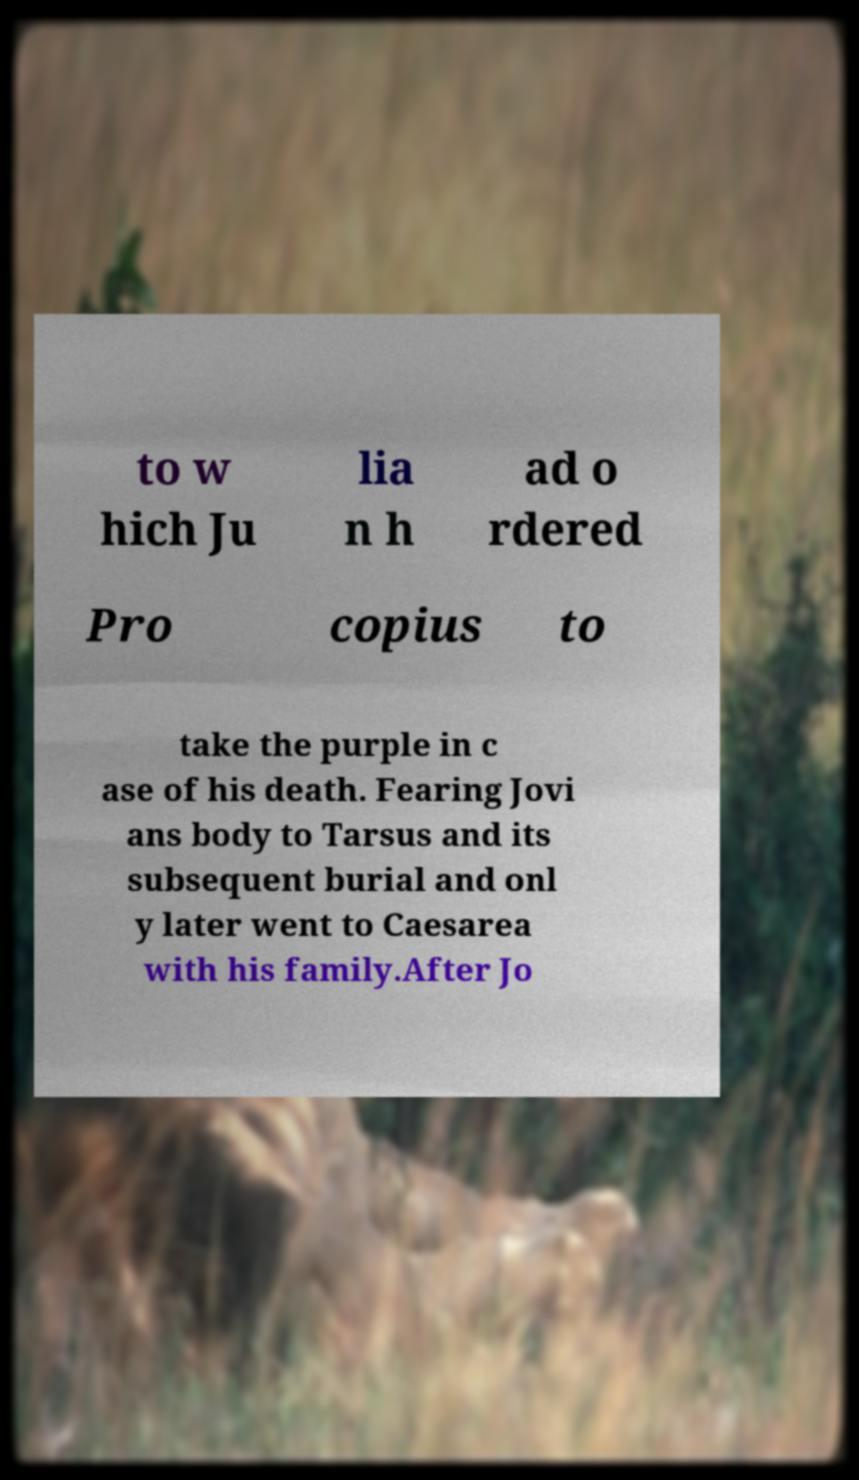What messages or text are displayed in this image? I need them in a readable, typed format. to w hich Ju lia n h ad o rdered Pro copius to take the purple in c ase of his death. Fearing Jovi ans body to Tarsus and its subsequent burial and onl y later went to Caesarea with his family.After Jo 